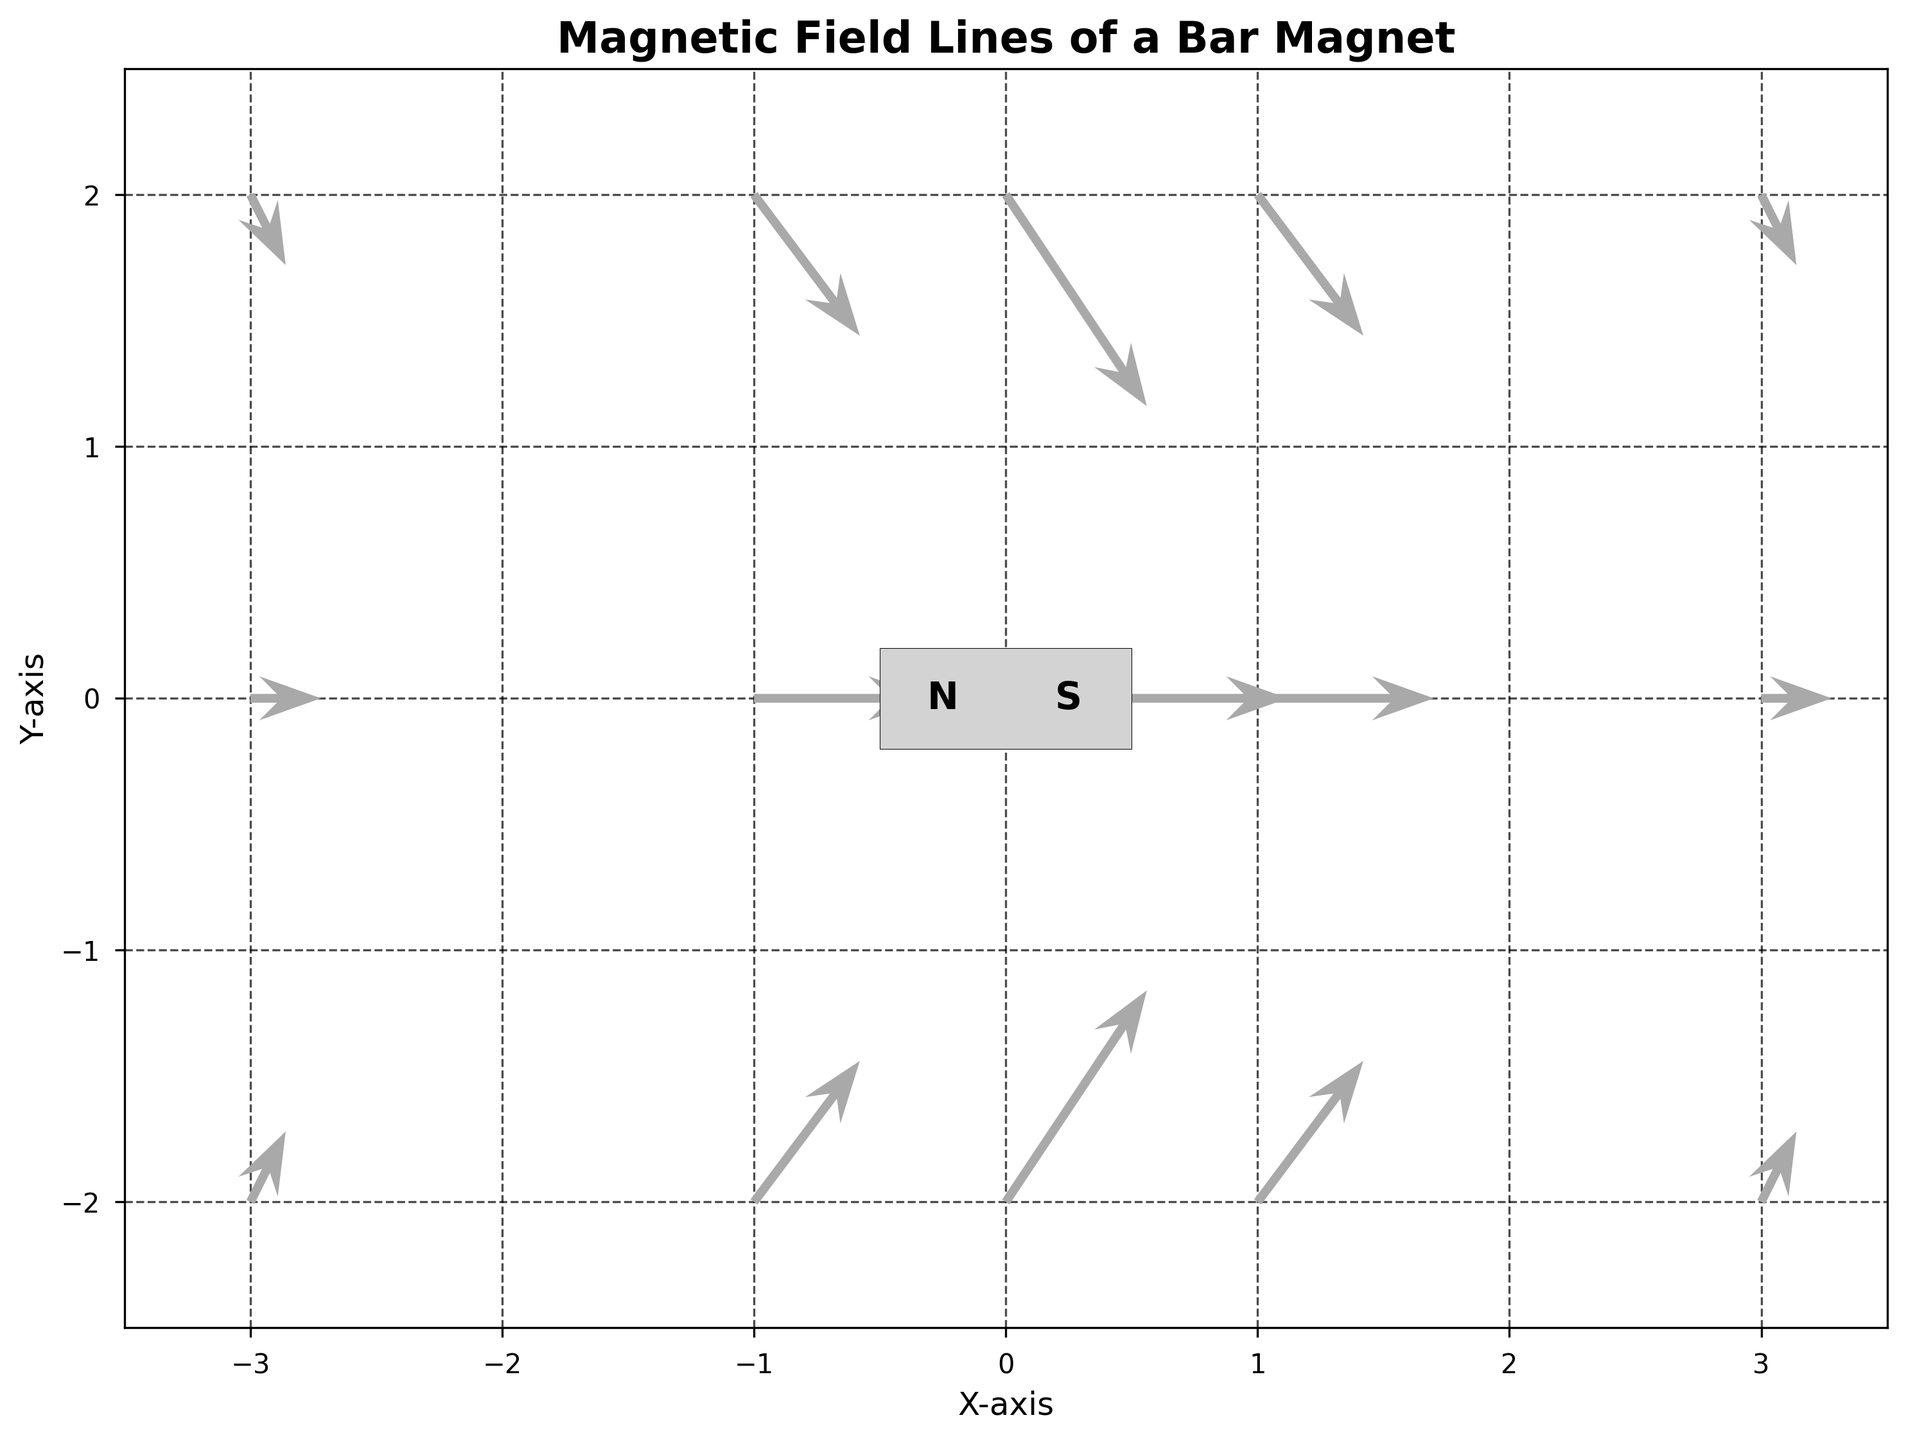What is the title of the plot? The title is written at the top of the plot. It reads "Magnetic Field Lines of a Bar Magnet".
Answer: Magnetic Field Lines of a Bar Magnet What are the labels of the x-axis and y-axis? The labels can be found on the respective axes of the plot. The x-axis is labeled "X-axis" and the y-axis is labeled "Y-axis".
Answer: X-axis and Y-axis How many quiver arrows are there in total in the plot? By counting each individual arrow shown in the plot, we find there are arrows at each (x, y) coordinate given by the data.
Answer: 15 Which side of the bar magnet is labeled "N"? The plot shows a rectangular representation of the bar magnet in the center, with the label "N" on the left side of the bar magnet.
Answer: Left What is the direction of the magnetic field at the coordinate (-3,0)? The quiver arrow at (-3,0) points horizontally to the right. This indicates a magnetic field direction from left to right at this point.
Answer: Right What is the x-coordinate that shows the longest arrow in the plot? By observing the lengths of the quiver arrows, the longest arrow appears at the x-coordinate 0.
Answer: 0 Between the coordinates (1,2) and (1,-2), which one has a stronger magnetic field? The strength of the magnetic field can be inferred by the length of the arrows. The arrows at (1,2) and (1,-2) have the same length.
Answer: Equal What happens to the magnetic field direction at (0,2)? The arrow at (0,2) points downward, indicating the magnetic field is directed towards the bottom at this point.
Answer: Downward How does the arrow at (3,2) compare in length to the arrow at (0,2)? The arrows at (3,2) and (0,2) are compared by their lengths. The arrow at (0,2) is longer than the one at (3,2).
Answer: Shorter Refer to the arrows coming out of the left and right sides of the bar magnet. Do they point in the same or opposite directions? Looking at the arrows near both sides of the bar magnet, they point in opposite directions from each other.
Answer: Opposite 